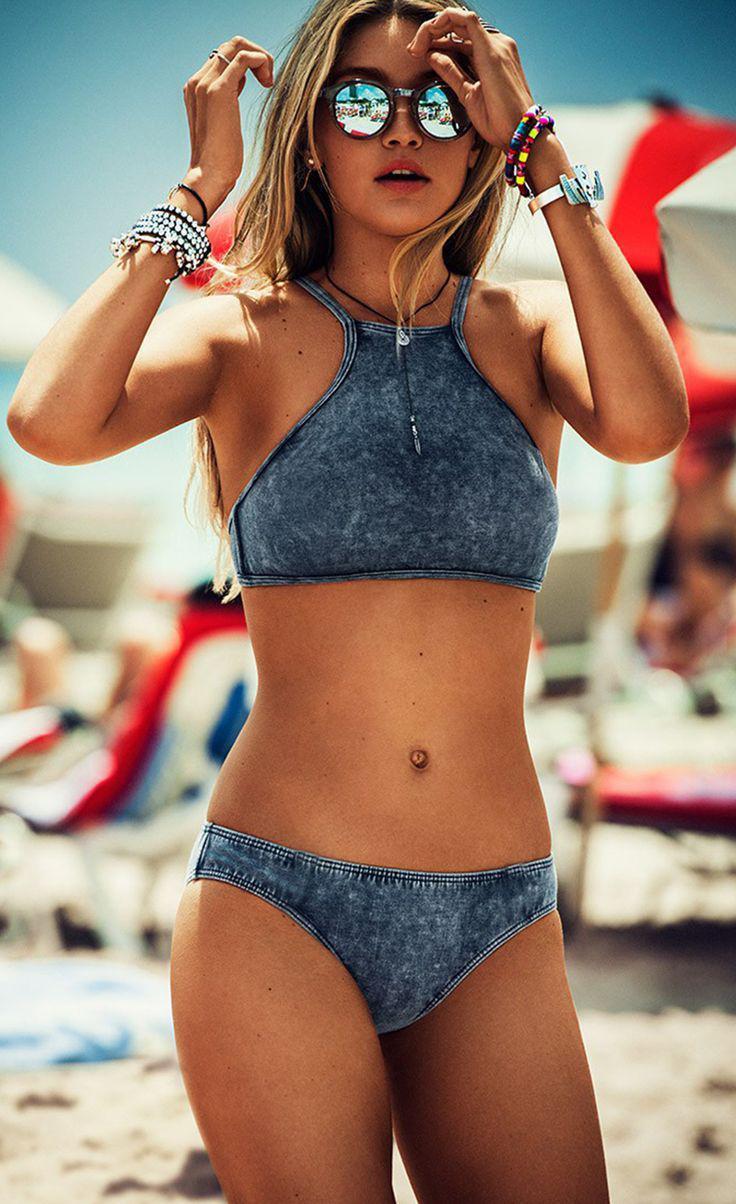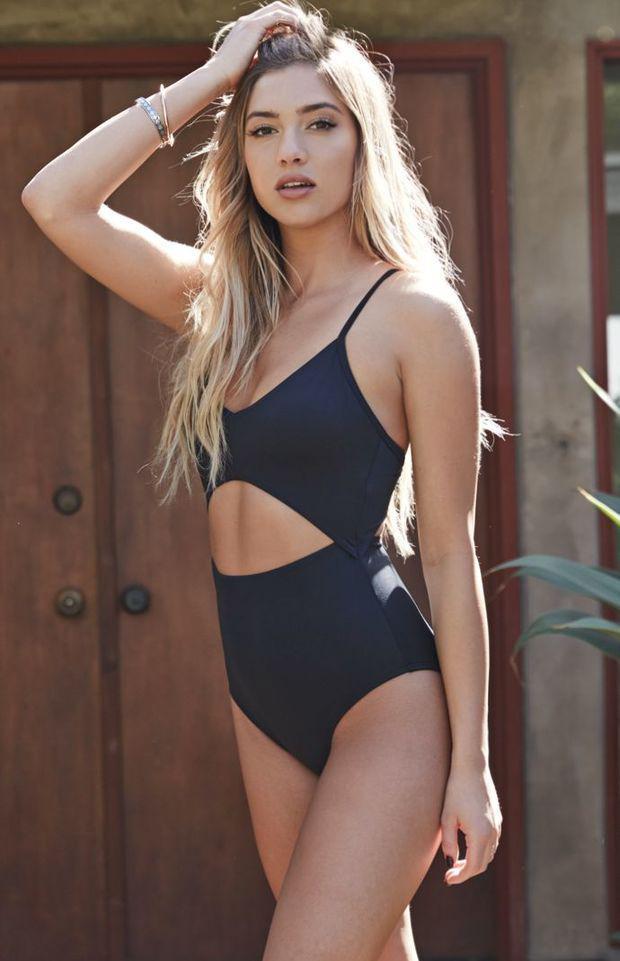The first image is the image on the left, the second image is the image on the right. Assess this claim about the two images: "There is a woman wearing a hat.". Correct or not? Answer yes or no. No. 